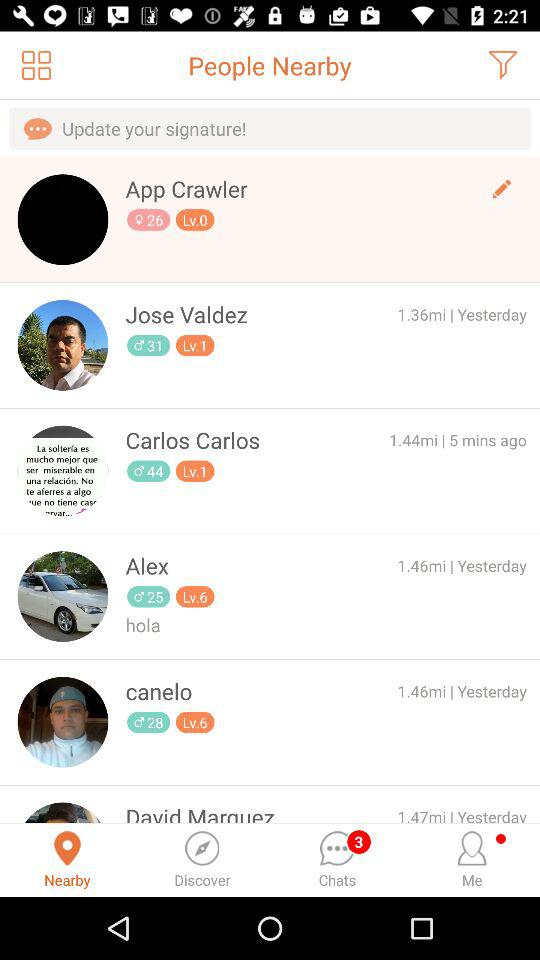What is the age of Alex? Alex is 25 years old. 